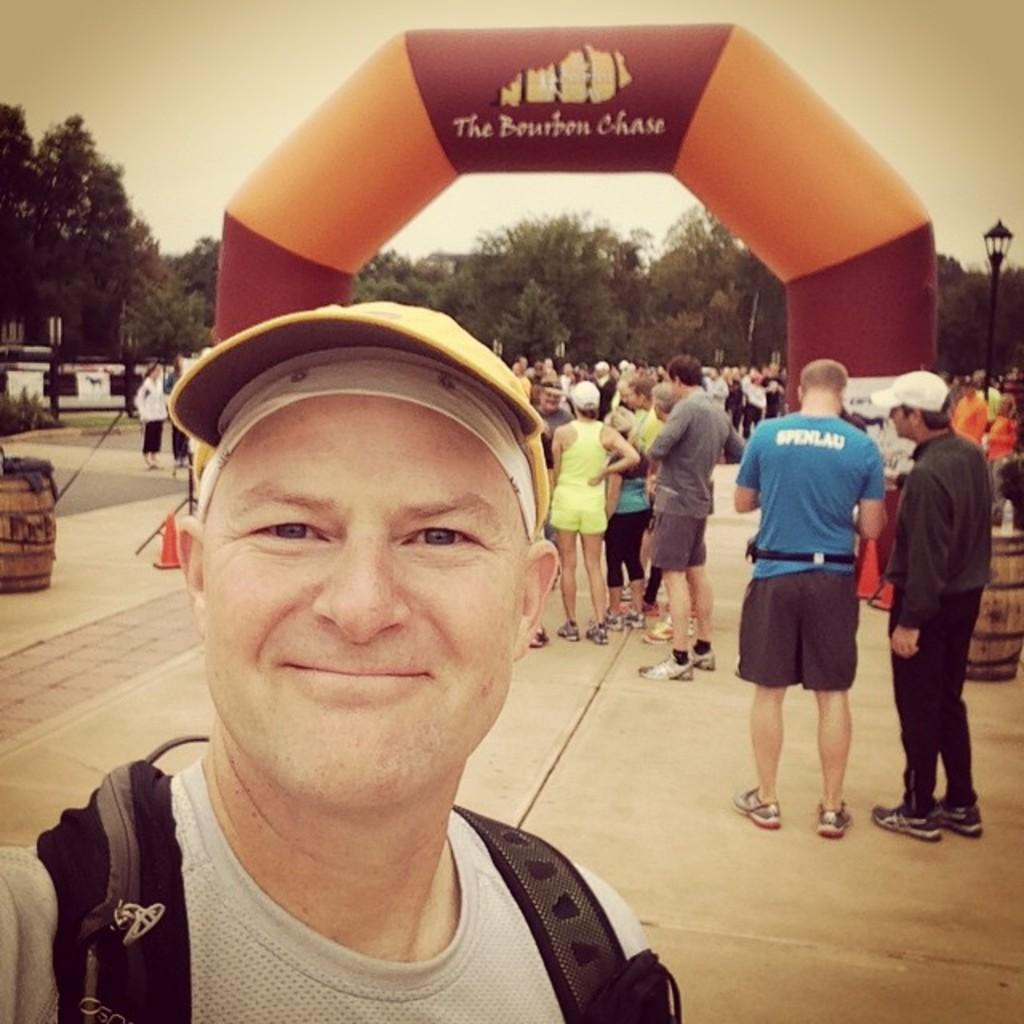Who is the main subject in the front of the image? There is a person standing in the front of the image. What can be seen in the background of the image? There is a group of people, an arch, a street pole, drums, trees, and the sky visible in the background of the image. What might be the occasion or event in the image? The presence of drums and a group of people in the background suggests that there might be an event or gathering taking place. What type of question is the chicken asking in the image? There is no chicken present in the image, so it is not possible to answer that question. 